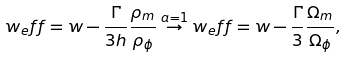<formula> <loc_0><loc_0><loc_500><loc_500>w _ { e } f f = w - \frac { \Gamma } { 3 h } \frac { \rho _ { m } } { \rho _ { \phi } } \stackrel { a = 1 } { \rightarrow } w _ { e } f f = w - \frac { \Gamma } { 3 } \frac { \Omega _ { m } } { \Omega _ { \phi } } ,</formula> 